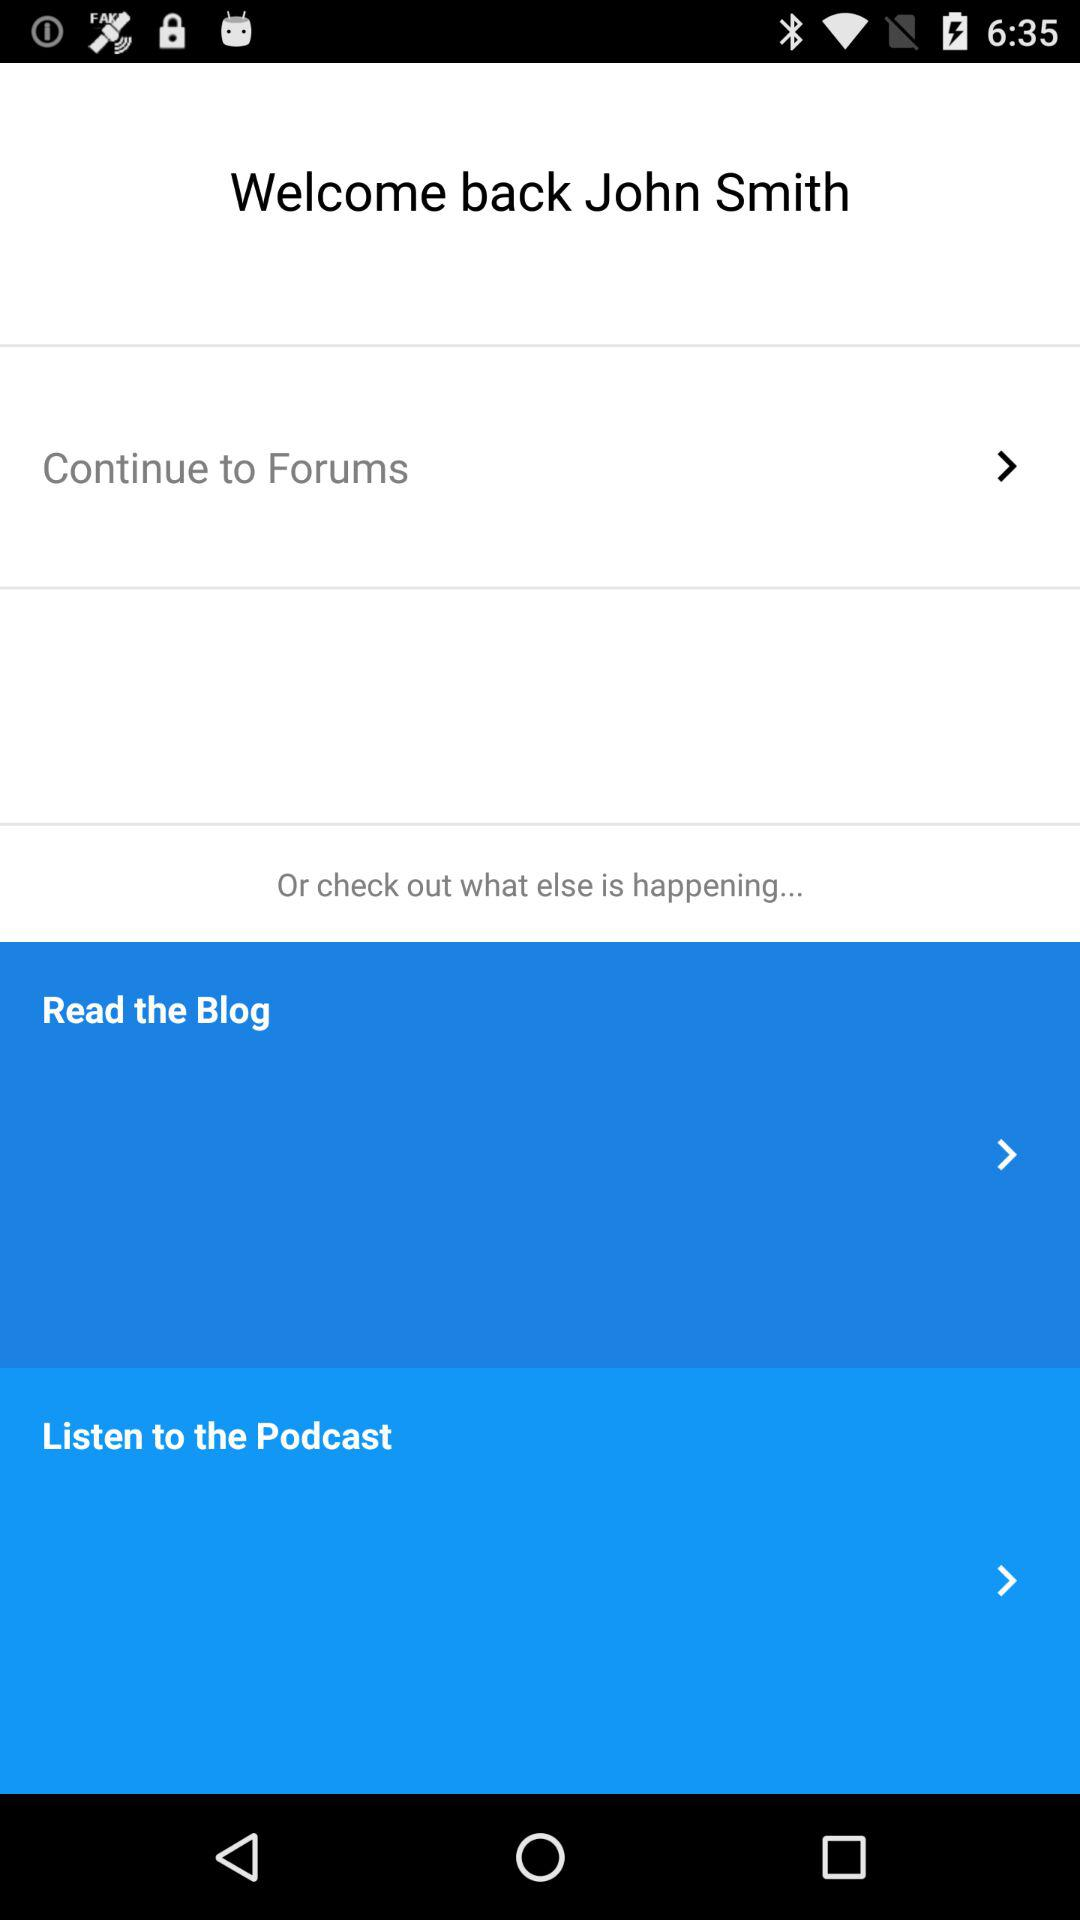How many options are there in total?
Answer the question using a single word or phrase. 3 